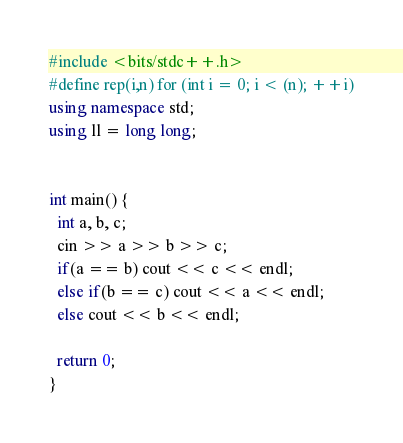<code> <loc_0><loc_0><loc_500><loc_500><_C++_>#include <bits/stdc++.h>
#define rep(i,n) for (int i = 0; i < (n); ++i)
using namespace std;
using ll = long long;


int main() {
  int a, b, c;
  cin >> a >> b >> c;
  if(a == b) cout << c << endl;
  else if(b == c) cout << a << endl;
  else cout << b << endl;
  
  return 0;
}</code> 